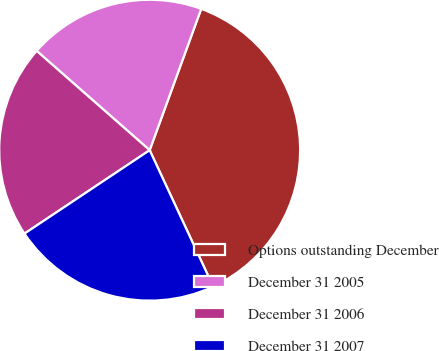Convert chart to OTSL. <chart><loc_0><loc_0><loc_500><loc_500><pie_chart><fcel>Options outstanding December<fcel>December 31 2005<fcel>December 31 2006<fcel>December 31 2007<nl><fcel>37.5%<fcel>19.09%<fcel>20.83%<fcel>22.58%<nl></chart> 